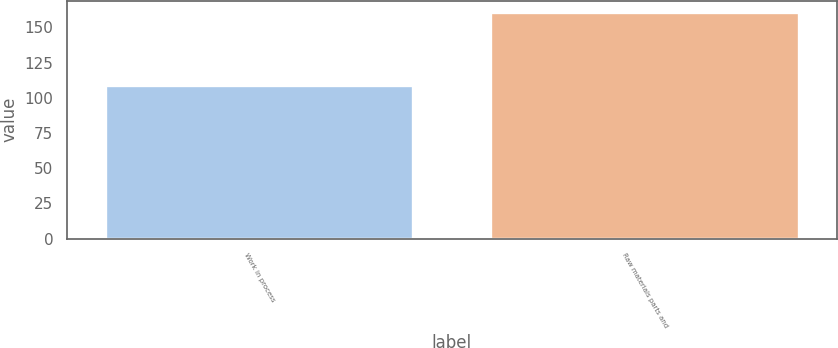<chart> <loc_0><loc_0><loc_500><loc_500><bar_chart><fcel>Work in process<fcel>Raw materials parts and<nl><fcel>109.1<fcel>160.9<nl></chart> 